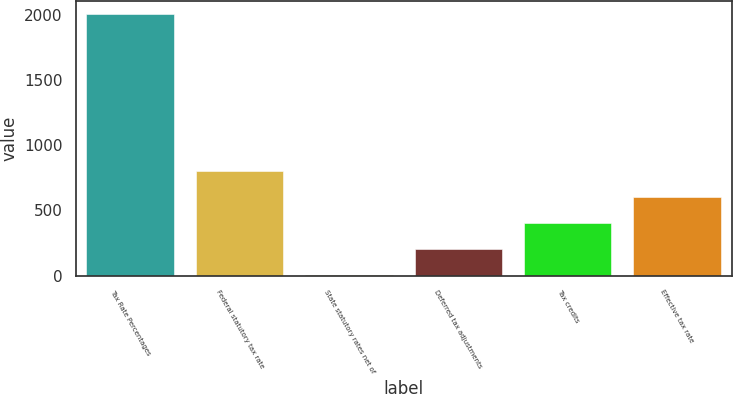Convert chart to OTSL. <chart><loc_0><loc_0><loc_500><loc_500><bar_chart><fcel>Tax Rate Percentages<fcel>Federal statutory tax rate<fcel>State statutory rates net of<fcel>Deferred tax adjustments<fcel>Tax credits<fcel>Effective tax rate<nl><fcel>2004<fcel>803.34<fcel>2.9<fcel>203.01<fcel>403.12<fcel>603.23<nl></chart> 